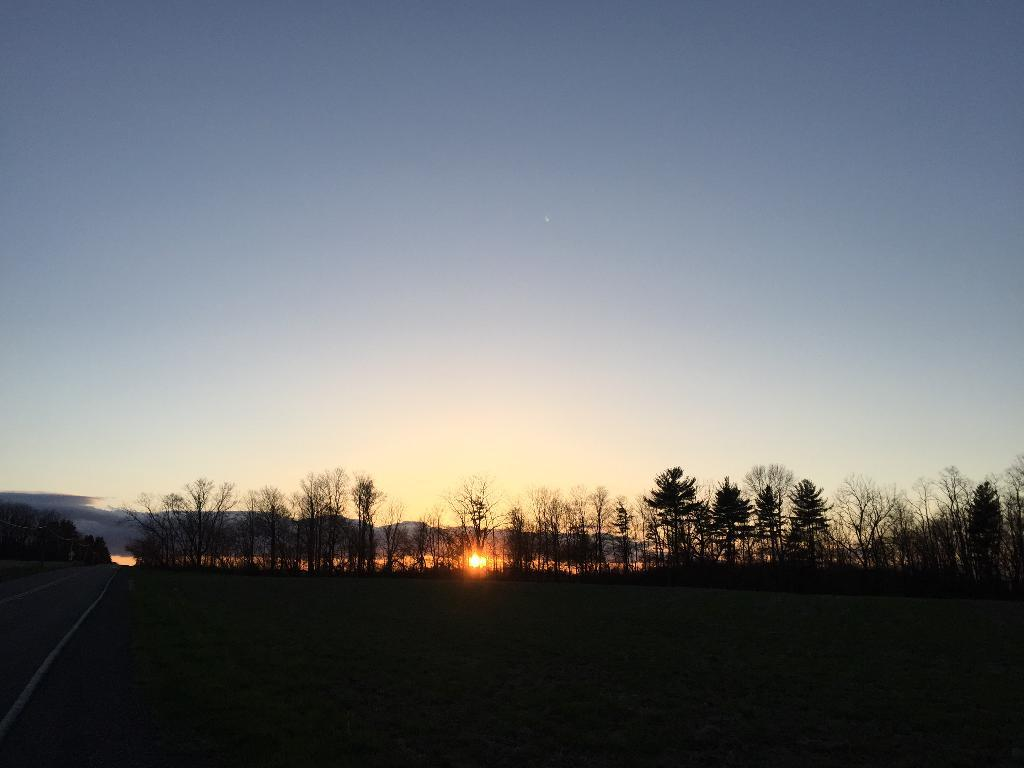What type of vegetation is present in the image? There is grass in the image. What type of man-made structure can be seen in the image? There is a road in the image. What other natural elements are present in the image? There are trees and mountains in the image. What part of the natural environment is visible in the image? The sky is visible in the image. What type of whip is being used by the achiever in the image? There is no achiever or whip present in the image. 